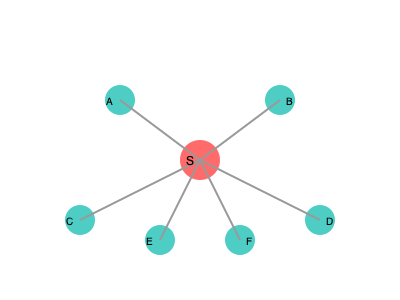In the context of misinformation spread on social networks, the graph above represents a network where node S is the source of a piece of misinformation. If the probability of misinformation being shared from one node to another is 0.5, what is the probability that at least 4 out of the 6 connected nodes (A, B, C, D, E, F) will receive and potentially spread the misinformation? To solve this problem, we need to follow these steps:

1. Understand the scenario: Each connected node has a 0.5 probability of receiving and potentially spreading the misinformation.

2. Identify the possible outcomes: We need to calculate the probability of 4, 5, or 6 nodes receiving the misinformation.

3. Use the binomial probability formula: The probability of exactly $k$ successes in $n$ trials is given by:

   $P(X = k) = \binom{n}{k} p^k (1-p)^{n-k}$

   Where $n$ is the number of trials, $k$ is the number of successes, $p$ is the probability of success on each trial.

4. Calculate the probabilities:
   For 4 nodes: $P(X = 4) = \binom{6}{4} (0.5)^4 (0.5)^2 = 15 \times 0.0625 \times 0.25 = 0.234375$
   For 5 nodes: $P(X = 5) = \binom{6}{5} (0.5)^5 (0.5)^1 = 6 \times 0.03125 \times 0.5 = 0.09375$
   For 6 nodes: $P(X = 6) = \binom{6}{6} (0.5)^6 (0.5)^0 = 1 \times 0.015625 \times 1 = 0.015625$

5. Sum the probabilities:
   $P(X \geq 4) = P(X = 4) + P(X = 5) + P(X = 6)$
   $= 0.234375 + 0.09375 + 0.015625 = 0.34375$

6. Convert to percentage: $0.34375 \times 100\% = 34.375\%$

Therefore, the probability that at least 4 out of the 6 connected nodes will receive and potentially spread the misinformation is 34.375%.
Answer: 34.375% 